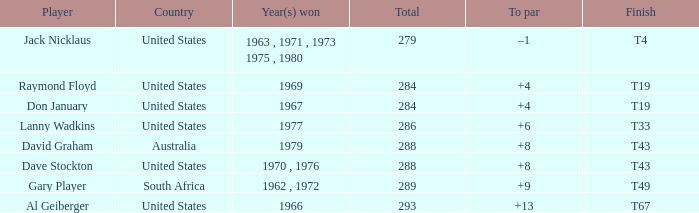What is the average total in 1969? 284.0. 